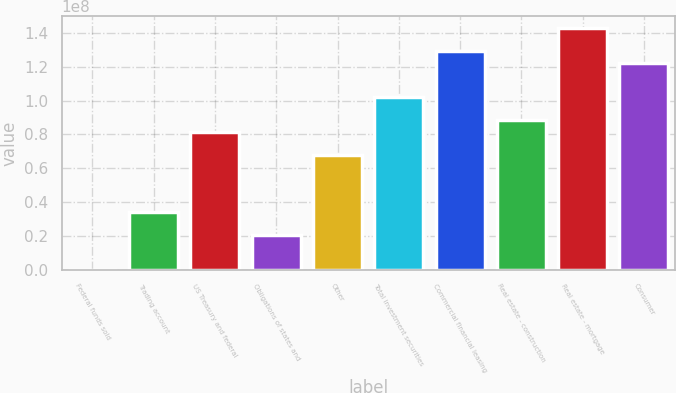Convert chart. <chart><loc_0><loc_0><loc_500><loc_500><bar_chart><fcel>Federal funds sold<fcel>Trading account<fcel>US Treasury and federal<fcel>Obligations of states and<fcel>Other<fcel>Total investment securities<fcel>Commercial financial leasing<fcel>Real estate - construction<fcel>Real estate - mortgage<fcel>Consumer<nl><fcel>25000<fcel>3.40231e+07<fcel>8.16205e+07<fcel>2.04239e+07<fcel>6.80213e+07<fcel>1.02019e+08<fcel>1.29218e+08<fcel>8.84201e+07<fcel>1.42817e+08<fcel>1.22418e+08<nl></chart> 